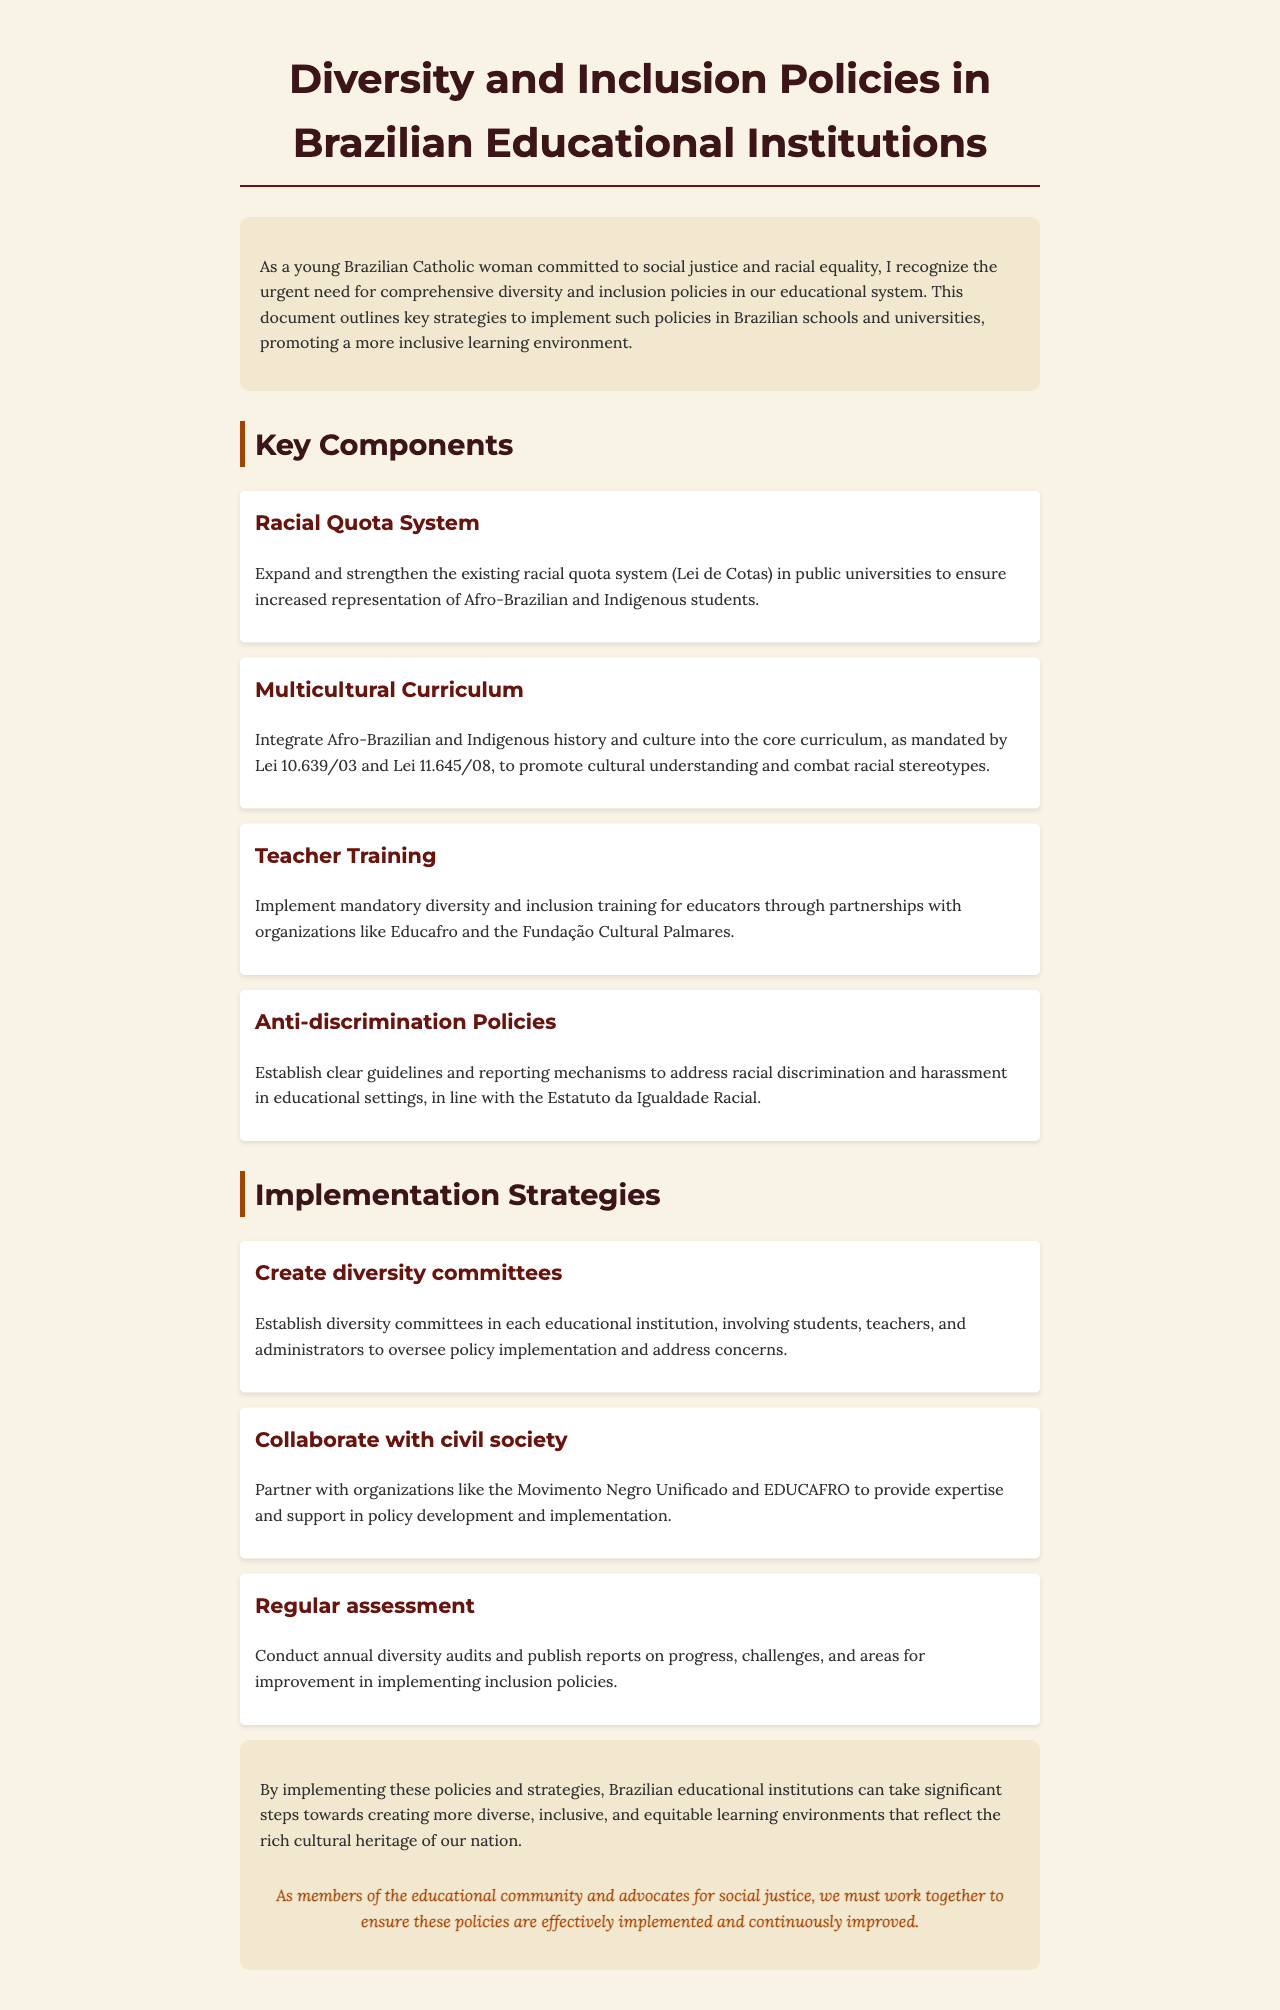What is the title of the document? The title of the document is prominently displayed at the top, stating its focus on diversity and inclusion policies.
Answer: Diversity and Inclusion Policies in Brazilian Educational Institutions What is the primary objective of the document? It outlines the need for comprehensive diversity and inclusion policies in educational institutions to promote a more inclusive learning environment.
Answer: Promote a more inclusive learning environment What year was the Racial Quota System established? The document refers to the Racial Quota System and its connection to public universities, which is part of a larger legislative context.
Answer: Not specified in the document Which two laws mandate the integration of Afro-Brazilian and Indigenous history? The document specifically names two laws related to the educational curriculum that are closely tied to diversity and inclusion efforts.
Answer: Lei 10.639/03 and Lei 11.645/08 Which organizations are mentioned for teacher training partnerships? It highlights two organizations focused on educator training to ensure effective implementation of diversity policies.
Answer: Educafro and Fundação Cultural Palmares What is one suggested implementation strategy mentioned in the document? It provides specific strategies for implementing diversity policies, including establishing committees within educational institutions.
Answer: Create diversity committees How often should diversity audits be conducted? The document suggests a frequency for assessments to ensure ongoing improvement and accountability in diversity policies.
Answer: Annually What is the call to action for educational community members? It encourages a collective effort among those involved in education to ensure the effectiveness of the proposed policies and their continuous improvement.
Answer: Work together to ensure these policies are effectively implemented 